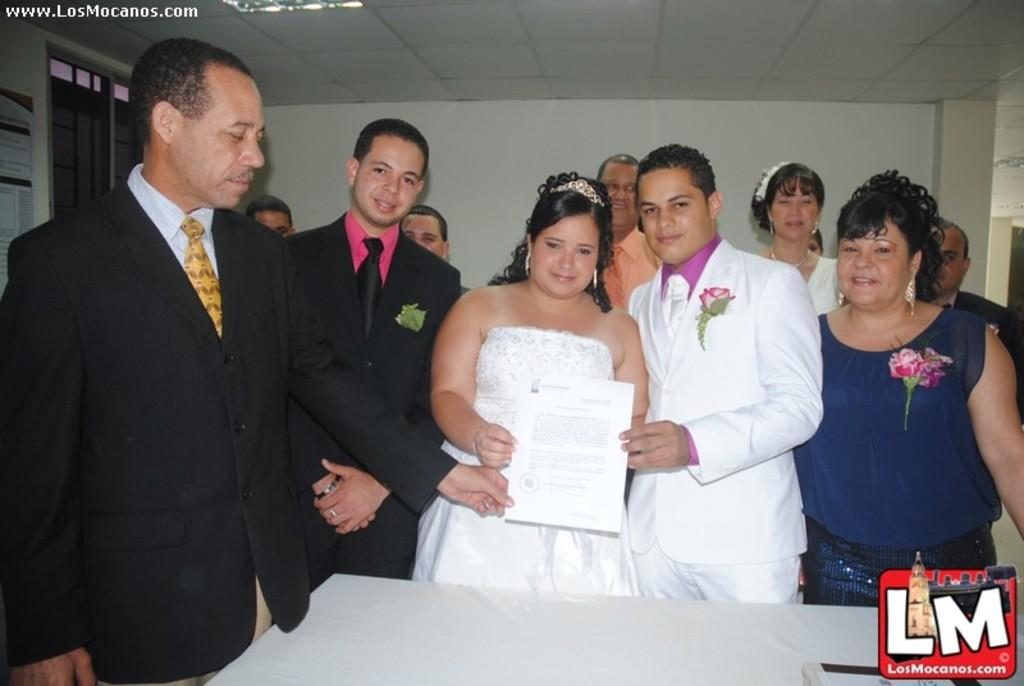What is happening in the center of the image? There are many persons standing at the table in the center of the image. Can you describe the scene in the background? There are persons visible in the background, along with a wall, a window, and light. How many people can be seen in the image? It is not possible to determine the exact number of people from the provided facts, but there are many persons standing at the table and some visible in the background. What type of line can be seen connecting the persons in the image? There is no line connecting the persons in the image. Can you tell me how many kittens are sitting on the table in the image? There are no kittens or lines present in the image; it features a table with many persons standing around it. 